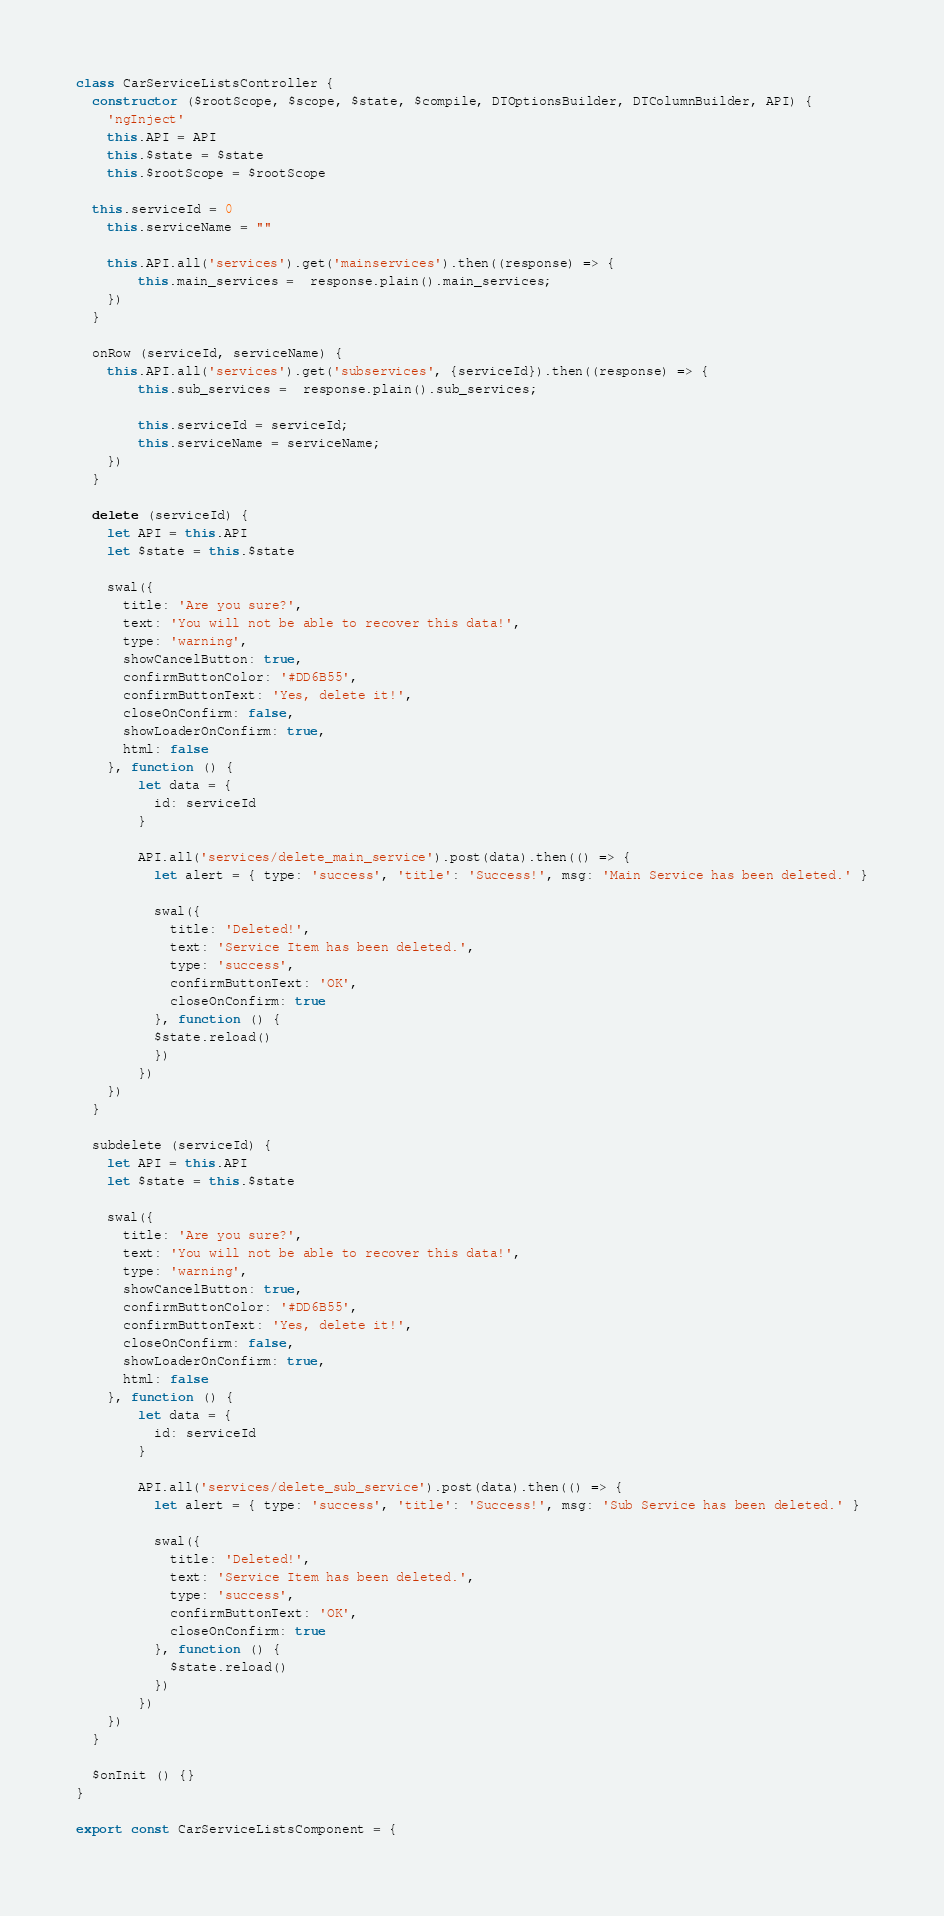<code> <loc_0><loc_0><loc_500><loc_500><_JavaScript_>class CarServiceListsController {
  constructor ($rootScope, $scope, $state, $compile, DTOptionsBuilder, DTColumnBuilder, API) {
    'ngInject'
    this.API = API
    this.$state = $state
    this.$rootScope = $rootScope

  this.serviceId = 0
	this.serviceName = ""
	
	this.API.all('services').get('mainservices').then((response) => {
		this.main_services =  response.plain().main_services;
	})
  }
	
  onRow (serviceId, serviceName) {
  	this.API.all('services').get('subservices', {serviceId}).then((response) => {
  		this.sub_services =  response.plain().sub_services;
  		
  		this.serviceId = serviceId;
  		this.serviceName = serviceName;
  	})
  }
  
  delete (serviceId) {
    let API = this.API
    let $state = this.$state
	
    swal({
      title: 'Are you sure?',
      text: 'You will not be able to recover this data!',
      type: 'warning',
      showCancelButton: true,
      confirmButtonColor: '#DD6B55',
      confirmButtonText: 'Yes, delete it!',
      closeOnConfirm: false,
      showLoaderOnConfirm: true,
      html: false
    }, function () {
    	let data = {
	      id: serviceId
	    }
	    
	    API.all('services/delete_main_service').post(data).then(() => {
	      let alert = { type: 'success', 'title': 'Success!', msg: 'Main Service has been deleted.' }
	      
	      swal({
	        title: 'Deleted!',
	        text: 'Service Item has been deleted.',
	        type: 'success',
	        confirmButtonText: 'OK',
	        closeOnConfirm: true
	      }, function () {
          $state.reload()
	      })
	    })
    })
  }
  
  subdelete (serviceId) {
    let API = this.API
    let $state = this.$state
  	
    swal({
      title: 'Are you sure?',
      text: 'You will not be able to recover this data!',
      type: 'warning',
      showCancelButton: true,
      confirmButtonColor: '#DD6B55',
      confirmButtonText: 'Yes, delete it!',
      closeOnConfirm: false,
      showLoaderOnConfirm: true,
      html: false
    }, function () {
    	let data = {
  	      id: serviceId
  	    }
  	    
  	    API.all('services/delete_sub_service').post(data).then(() => {
  	      let alert = { type: 'success', 'title': 'Success!', msg: 'Sub Service has been deleted.' }
  	      
  	      swal({
  	        title: 'Deleted!',
  	        text: 'Service Item has been deleted.',
  	        type: 'success',
  	        confirmButtonText: 'OK',
  	        closeOnConfirm: true
  	      }, function () {
            $state.reload()
  	      })
  	    })
    })
  }

  $onInit () {}
}

export const CarServiceListsComponent = {</code> 